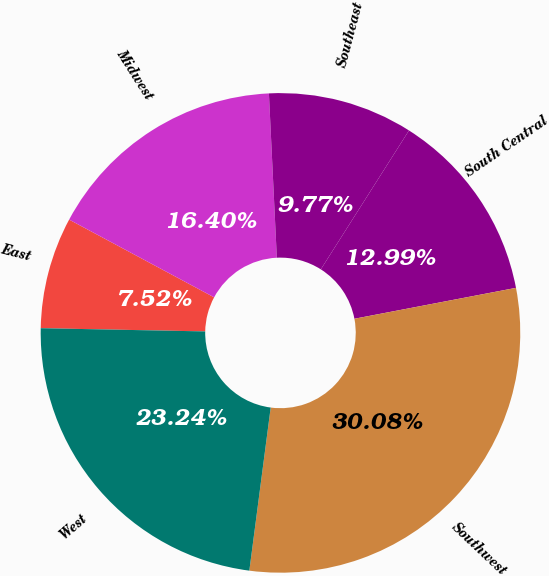Convert chart to OTSL. <chart><loc_0><loc_0><loc_500><loc_500><pie_chart><fcel>East<fcel>Midwest<fcel>Southeast<fcel>South Central<fcel>Southwest<fcel>West<nl><fcel>7.52%<fcel>16.4%<fcel>9.77%<fcel>12.99%<fcel>30.08%<fcel>23.24%<nl></chart> 